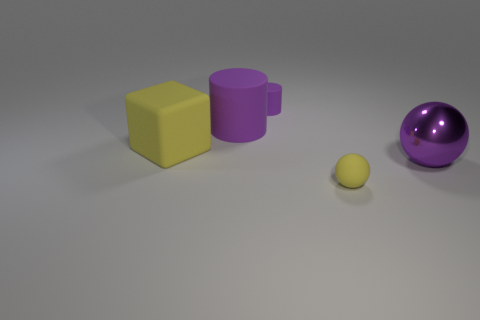Is there any other thing that is the same material as the purple sphere?
Give a very brief answer. No. What is the material of the tiny yellow ball?
Offer a terse response. Rubber. How many other things are the same shape as the purple metallic thing?
Offer a terse response. 1. The yellow matte ball has what size?
Keep it short and to the point. Small. There is a object that is both in front of the yellow rubber block and on the left side of the shiny object; what size is it?
Ensure brevity in your answer.  Small. What is the shape of the big matte object in front of the large purple cylinder?
Your answer should be compact. Cube. Is the tiny ball made of the same material as the large thing that is in front of the large yellow rubber cube?
Your answer should be very brief. No. Is the shape of the purple metallic object the same as the tiny yellow object?
Provide a succinct answer. Yes. There is another thing that is the same shape as the small yellow matte object; what is its material?
Make the answer very short. Metal. What color is the matte object that is both behind the large yellow thing and left of the small purple cylinder?
Provide a succinct answer. Purple. 